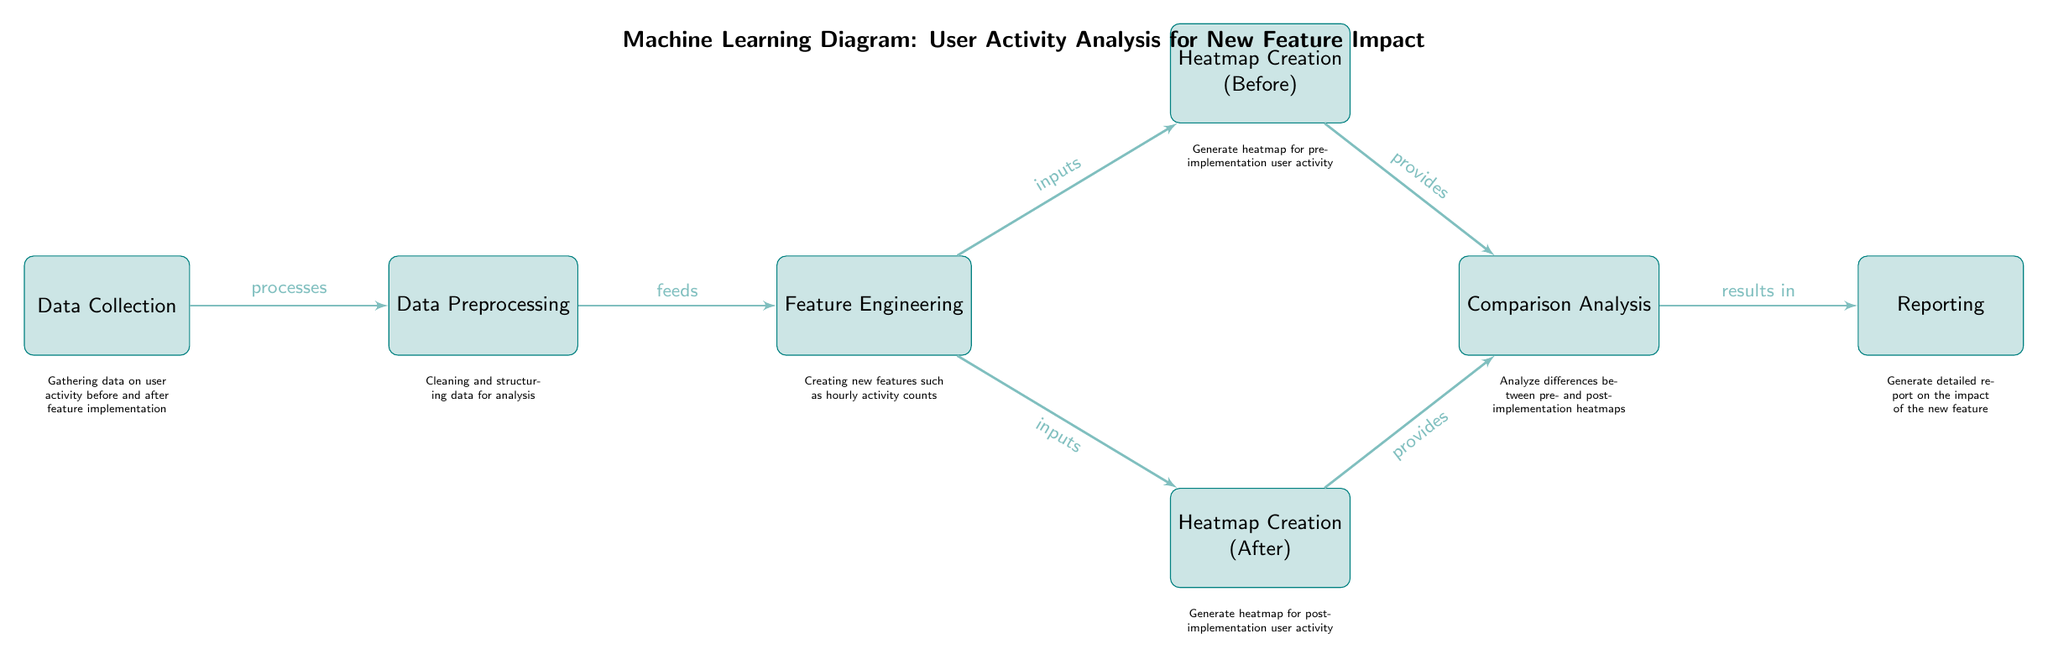What is the first node in the diagram? The first node in the diagram is labeled "Data Collection." It is located on the far left, which indicates it is the initial step in the analysis process.
Answer: Data Collection How many nodes are present in the diagram? By counting each defined box in the diagram, including the title and the numerous steps, there are a total of seven nodes in the diagram.
Answer: Seven What type of analysis is being conducted in this diagram? The analysis involves a "Comparison Analysis" as indicated in the diagram. This is represented as a node that connects heatmap data from the pre- and post-implementation.
Answer: Comparison Analysis Which node generates the heatmap for user activity before the new feature? The node that generates the heatmap for user activity before the new feature is labeled "Heatmap Creation (Before)." This can be found positioned at the top right of the "Feature Engineering" node.
Answer: Heatmap Creation (Before) What is the relationship between "Heatmap Creation (After)" and "Comparison Analysis"? The relationship is that "Heatmap Creation (After)" provides data to the "Comparison Analysis" node, indicating that it contributes to the analysis of user activity post-feature implementation.
Answer: Provides Which node is directly after "Feature Engineering"? The next node after "Feature Engineering" is split into two paths leading to "Heatmap Creation (Before)" and "Heatmap Creation (After)," indicating that it supplies input data to both.
Answer: Heatmap Creation (Before) and Heatmap Creation (After) What does the "Reporting" node indicate? The "Reporting" node indicates the generation of a detailed report on the impact of the new feature, which is the final output step of the analysis.
Answer: Generate detailed report on the impact of the new feature What action follows the creation of heatmaps in the diagram? Following the creation of heatmaps (both before and after), the next action is "Comparison Analysis," where the differences between the two heatmaps are analyzed.
Answer: Comparison Analysis What is the purpose of the "Data Preprocessing" node? The purpose of the "Data Preprocessing" node is to clean and structure the data for analysis, which is crucial for the following feature engineering steps.
Answer: Cleaning and structuring data for analysis 